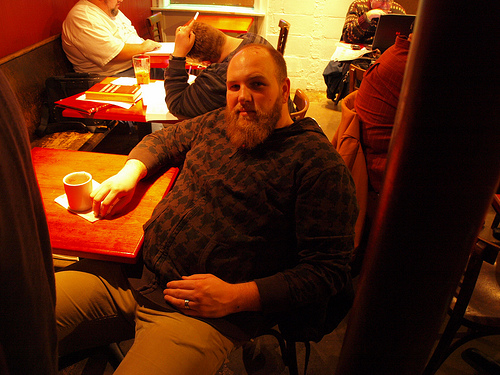<image>
Is there a ring under the jacket? No. The ring is not positioned under the jacket. The vertical relationship between these objects is different. 